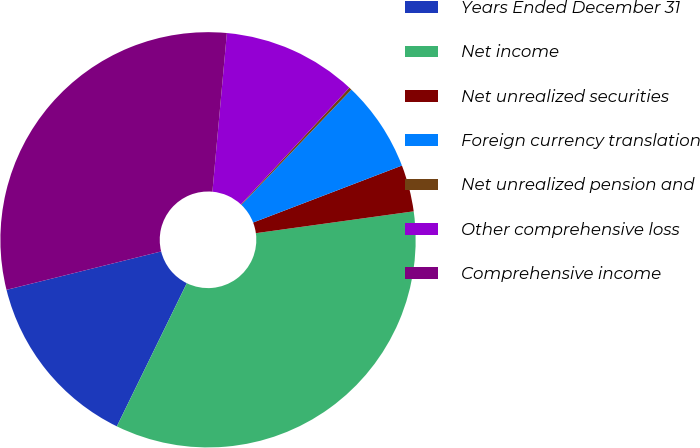Convert chart. <chart><loc_0><loc_0><loc_500><loc_500><pie_chart><fcel>Years Ended December 31<fcel>Net income<fcel>Net unrealized securities<fcel>Foreign currency translation<fcel>Net unrealized pension and<fcel>Other comprehensive loss<fcel>Comprehensive income<nl><fcel>13.89%<fcel>34.42%<fcel>3.63%<fcel>7.05%<fcel>0.21%<fcel>10.47%<fcel>30.32%<nl></chart> 